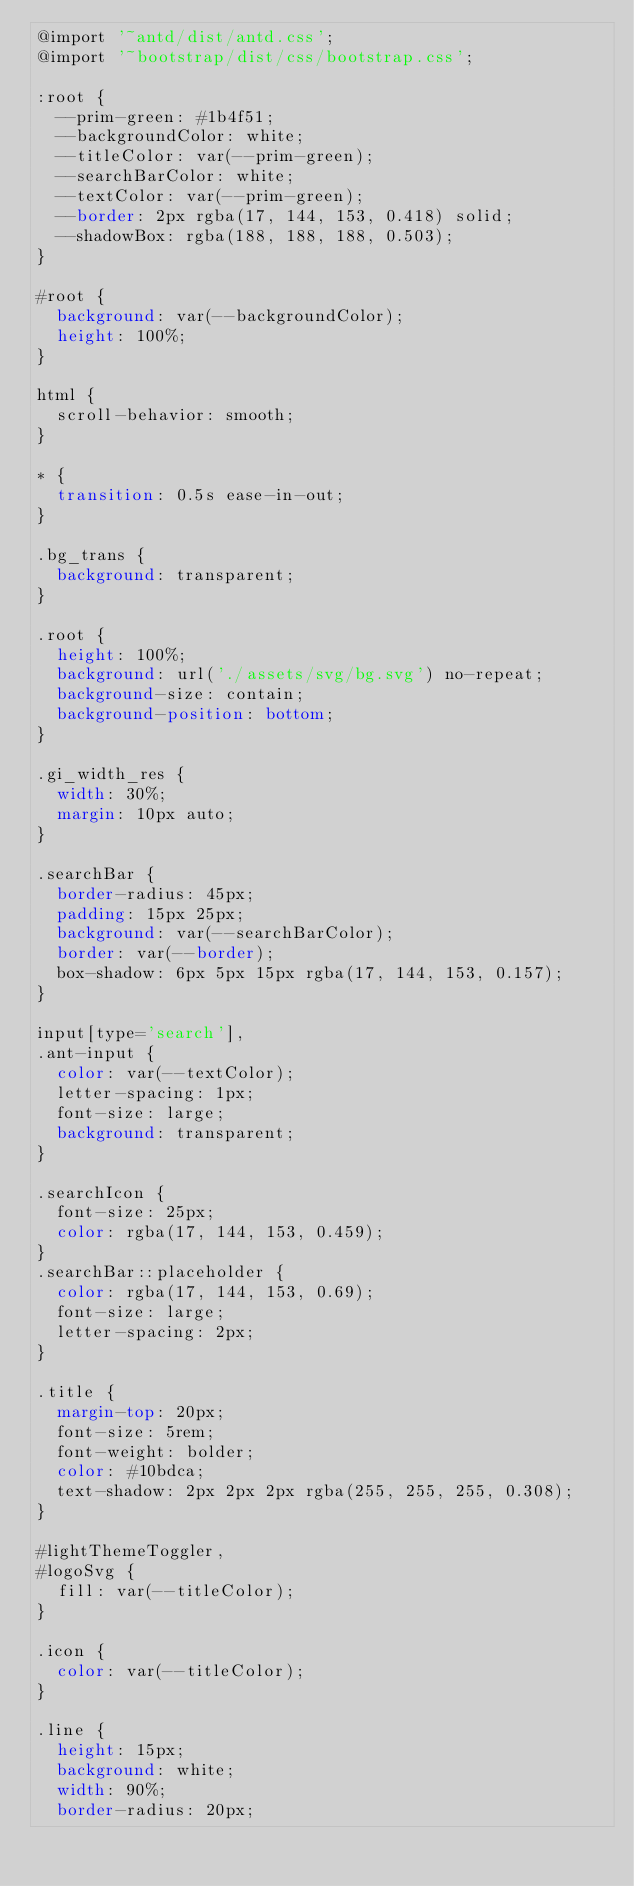Convert code to text. <code><loc_0><loc_0><loc_500><loc_500><_CSS_>@import '~antd/dist/antd.css';
@import '~bootstrap/dist/css/bootstrap.css';

:root {
	--prim-green: #1b4f51;
	--backgroundColor: white;
	--titleColor: var(--prim-green);
	--searchBarColor: white;
	--textColor: var(--prim-green);
	--border: 2px rgba(17, 144, 153, 0.418) solid;
	--shadowBox: rgba(188, 188, 188, 0.503);
}

#root {
	background: var(--backgroundColor);
	height: 100%;
}

html {
	scroll-behavior: smooth;
}

* {
	transition: 0.5s ease-in-out;
}

.bg_trans {
	background: transparent;
}

.root {
	height: 100%;
	background: url('./assets/svg/bg.svg') no-repeat;
	background-size: contain;
	background-position: bottom;
}

.gi_width_res {
	width: 30%;
	margin: 10px auto;
}

.searchBar {
	border-radius: 45px;
	padding: 15px 25px;
	background: var(--searchBarColor);
	border: var(--border);
	box-shadow: 6px 5px 15px rgba(17, 144, 153, 0.157);
}

input[type='search'],
.ant-input {
	color: var(--textColor);
	letter-spacing: 1px;
	font-size: large;
	background: transparent;
}

.searchIcon {
	font-size: 25px;
	color: rgba(17, 144, 153, 0.459);
}
.searchBar::placeholder {
	color: rgba(17, 144, 153, 0.69);
	font-size: large;
	letter-spacing: 2px;
}

.title {
	margin-top: 20px;
	font-size: 5rem;
	font-weight: bolder;
	color: #10bdca;
	text-shadow: 2px 2px 2px rgba(255, 255, 255, 0.308);
}

#lightThemeToggler,
#logoSvg {
	fill: var(--titleColor);
}

.icon {
	color: var(--titleColor);
}

.line {
	height: 15px;
	background: white;
	width: 90%;
	border-radius: 20px;</code> 